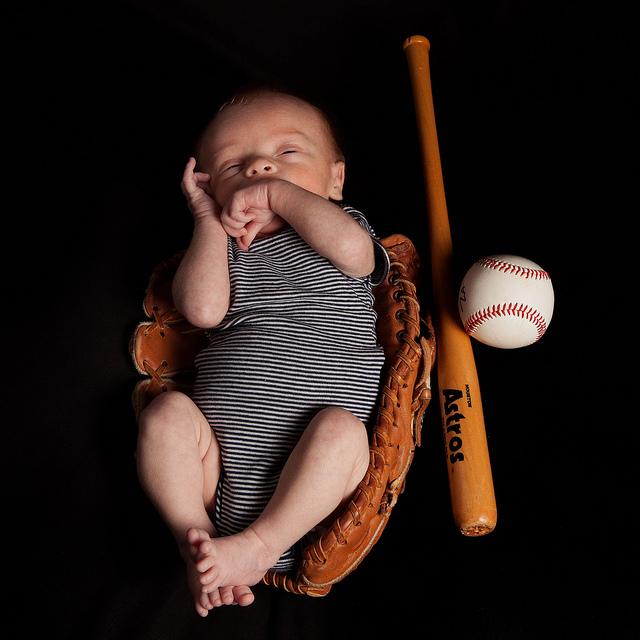About how old does the baby look to be?
Give a very brief answer. 6 months. What team is on the baseball bat?
Concise answer only. Astros. Is the baby awake?
Answer briefly. No. What is the glove used for?
Be succinct. Baseball. Has this mitt been used?
Keep it brief. Yes. 